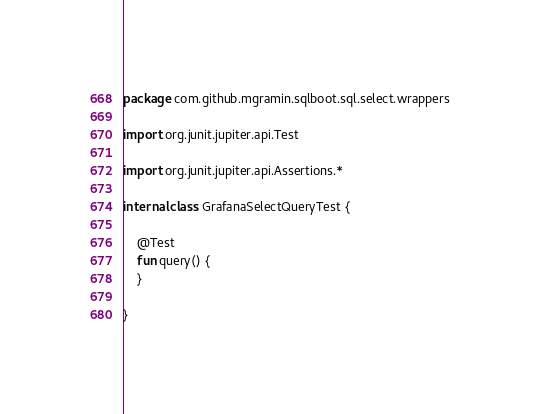Convert code to text. <code><loc_0><loc_0><loc_500><loc_500><_Kotlin_>package com.github.mgramin.sqlboot.sql.select.wrappers

import org.junit.jupiter.api.Test

import org.junit.jupiter.api.Assertions.*

internal class GrafanaSelectQueryTest {

    @Test
    fun query() {
    }

}</code> 